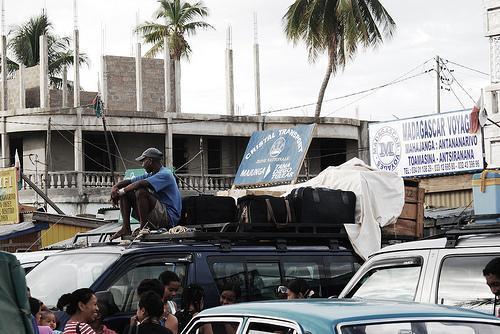How many cars are there?
Give a very brief answer. 3. How many black luggages are there?
Give a very brief answer. 3. 